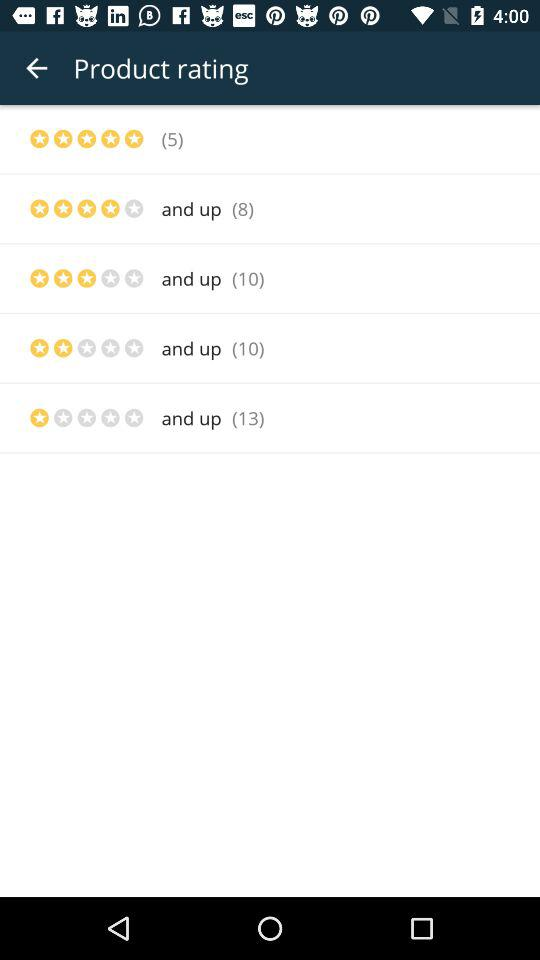How many people have given a five-star rating? There are five people who have given a five-star rating. 